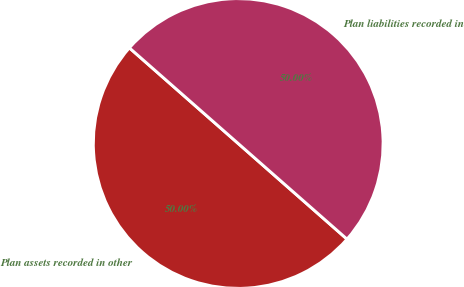Convert chart to OTSL. <chart><loc_0><loc_0><loc_500><loc_500><pie_chart><fcel>Plan assets recorded in other<fcel>Plan liabilities recorded in<nl><fcel>50.0%<fcel>50.0%<nl></chart> 